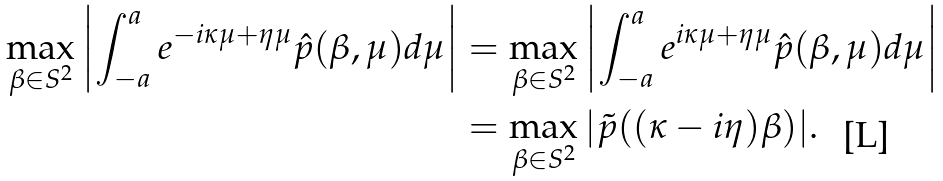Convert formula to latex. <formula><loc_0><loc_0><loc_500><loc_500>\max _ { \beta \in S ^ { 2 } } \left | \int _ { - a } ^ { a } e ^ { - i \kappa \mu + \eta \mu } \hat { p } ( \beta , \mu ) d \mu \right | & = \max _ { \beta \in S ^ { 2 } } \left | \int _ { - a } ^ { a } e ^ { i \kappa \mu + \eta \mu } \hat { p } ( \beta , \mu ) d \mu \right | \\ & = \max _ { \beta \in S ^ { 2 } } | \tilde { p } ( ( \kappa - i \eta ) \beta ) | .</formula> 